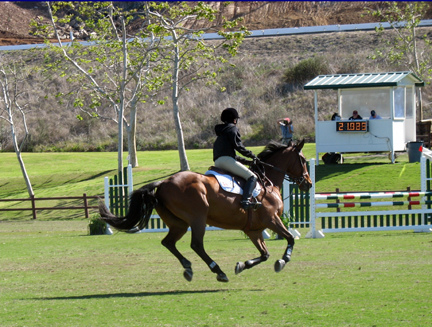<image>
Can you confirm if the horse is in the grass? No. The horse is not contained within the grass. These objects have a different spatial relationship. Where is the horse in relation to the grass? Is it above the grass? Yes. The horse is positioned above the grass in the vertical space, higher up in the scene. Where is the woman in relation to the horse? Is it behind the horse? No. The woman is not behind the horse. From this viewpoint, the woman appears to be positioned elsewhere in the scene. 